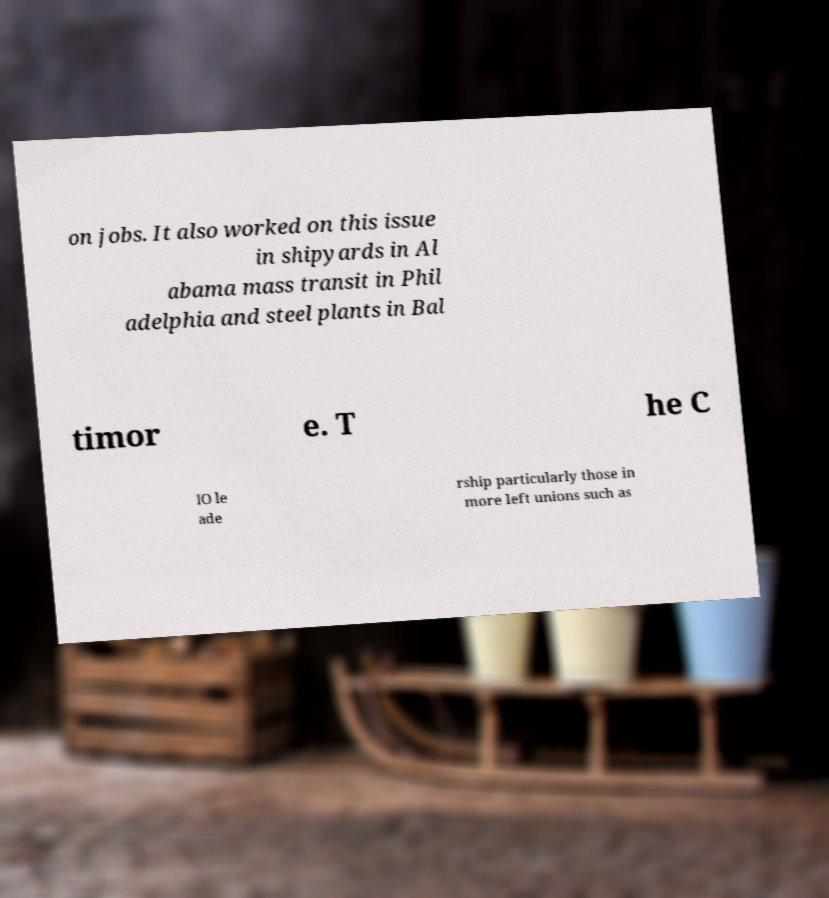For documentation purposes, I need the text within this image transcribed. Could you provide that? on jobs. It also worked on this issue in shipyards in Al abama mass transit in Phil adelphia and steel plants in Bal timor e. T he C IO le ade rship particularly those in more left unions such as 